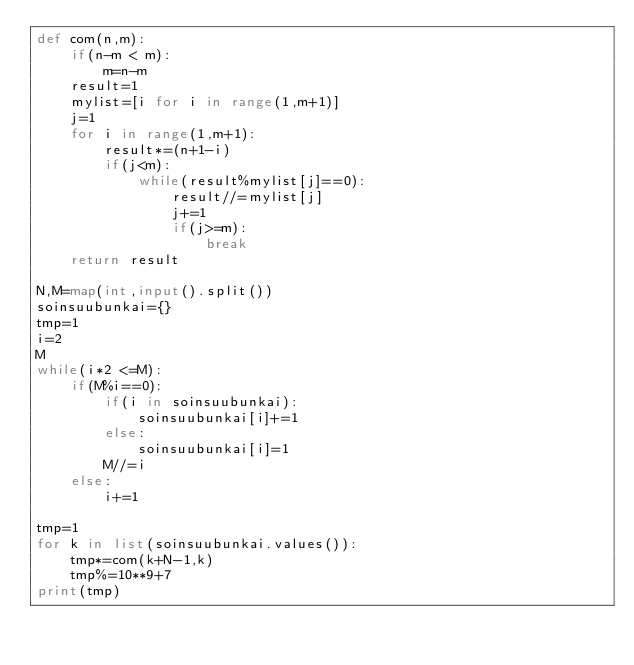<code> <loc_0><loc_0><loc_500><loc_500><_Python_>def com(n,m):
    if(n-m < m):
        m=n-m
    result=1
    mylist=[i for i in range(1,m+1)]
    j=1
    for i in range(1,m+1):
        result*=(n+1-i)
        if(j<m):
            while(result%mylist[j]==0):
                result//=mylist[j]
                j+=1
                if(j>=m):
                    break
    return result

N,M=map(int,input().split())
soinsuubunkai={}
tmp=1
i=2
M
while(i*2 <=M):
    if(M%i==0):
        if(i in soinsuubunkai):
            soinsuubunkai[i]+=1
        else:
            soinsuubunkai[i]=1
        M//=i
    else:
        i+=1

tmp=1
for k in list(soinsuubunkai.values()):
    tmp*=com(k+N-1,k)
    tmp%=10**9+7
print(tmp)</code> 